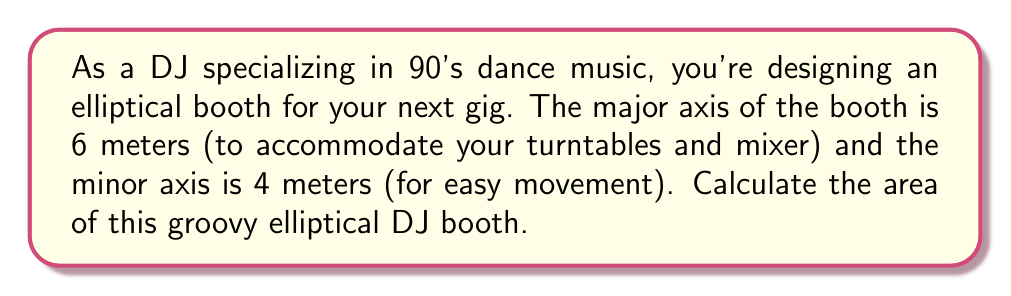Provide a solution to this math problem. Let's approach this step-by-step:

1) The formula for the area of an ellipse is:

   $$A = \pi ab$$

   where $a$ is half the length of the major axis and $b$ is half the length of the minor axis.

2) We're given:
   - Major axis = 6 meters
   - Minor axis = 4 meters

3) Therefore:
   $a = 6/2 = 3$ meters
   $b = 4/2 = 2$ meters

4) Substituting these values into our formula:

   $$A = \pi (3)(2)$$

5) Simplify:

   $$A = 6\pi$$ square meters

6) If we want to calculate the exact value:

   $$A = 6\pi \approx 18.85$$ square meters (rounded to 2 decimal places)

[asy]
unitsize(20);
path ellipse = scale(3,2)*unitcircle;
draw(ellipse);
draw((-3,0)--(3,0),arrow=Arrows(TeXHead));
draw((0,-2)--(0,2),arrow=Arrows(TeXHead));
label("6m", (3,0), E);
label("4m", (0,2), N);
[/asy]
Answer: $6\pi$ sq m or approximately 18.85 sq m 